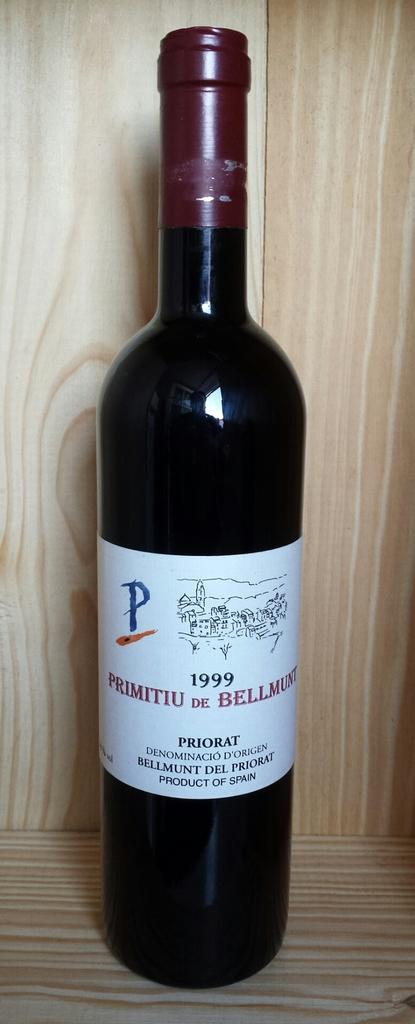<image>
Provide a brief description of the given image. A bottle of wine from 1999 is on a table. 